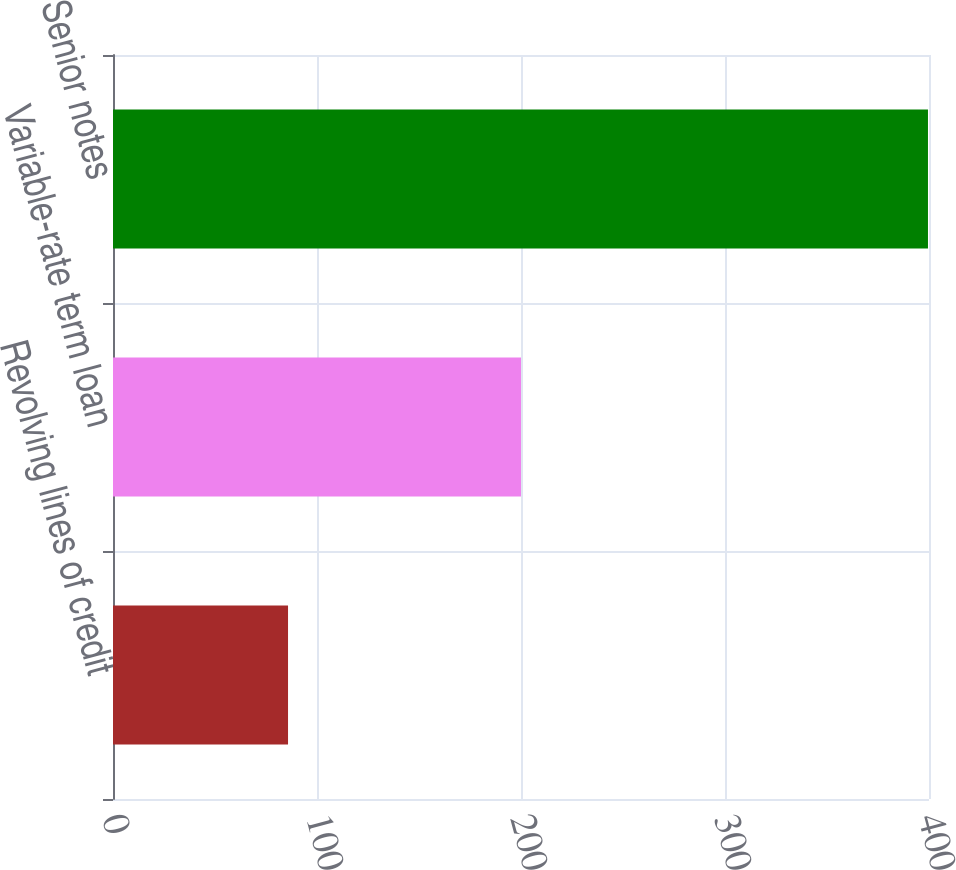Convert chart. <chart><loc_0><loc_0><loc_500><loc_500><bar_chart><fcel>Revolving lines of credit<fcel>Variable-rate term loan<fcel>Senior notes<nl><fcel>85.8<fcel>200<fcel>399.5<nl></chart> 